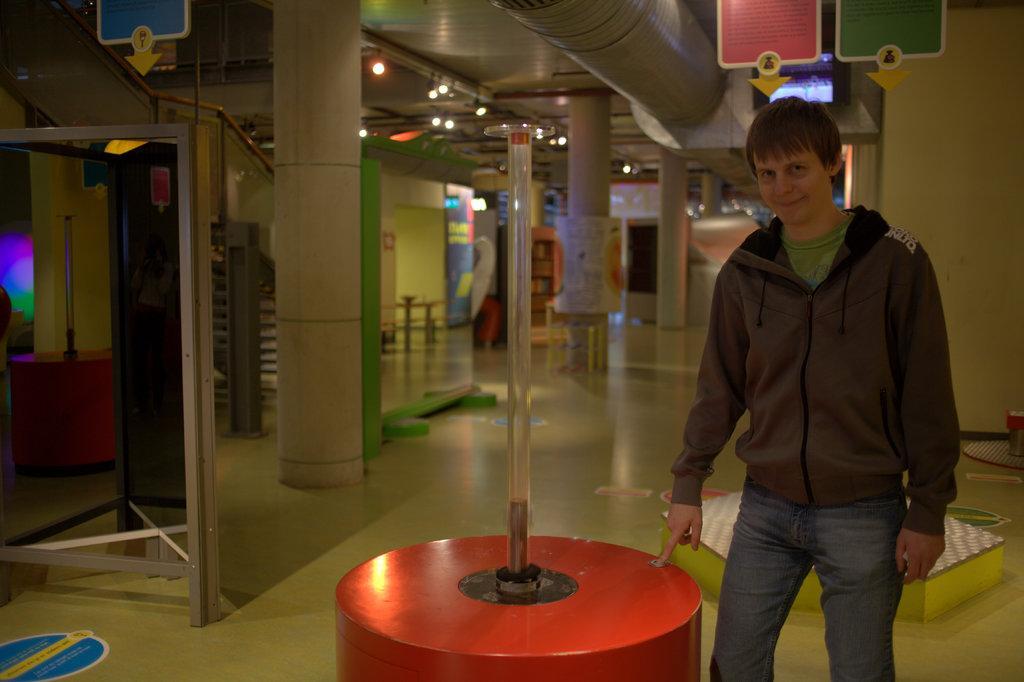How would you summarize this image in a sentence or two? In the picture i can see a person wearing jacket and blue color jeans standing near the object which is in red color and in the background of the image there are some pillars, boards, lights and top of the image there is clear sky. 